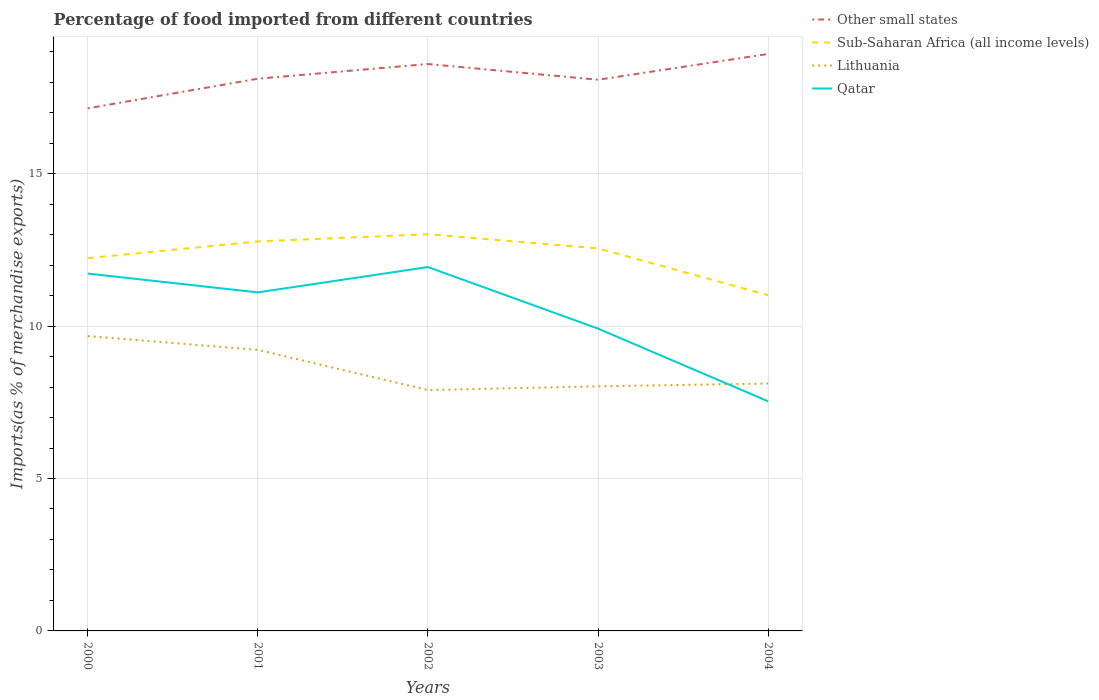How many different coloured lines are there?
Ensure brevity in your answer.  4. Is the number of lines equal to the number of legend labels?
Offer a very short reply. Yes. Across all years, what is the maximum percentage of imports to different countries in Sub-Saharan Africa (all income levels)?
Offer a very short reply. 11.01. What is the total percentage of imports to different countries in Lithuania in the graph?
Offer a terse response. 1.56. What is the difference between the highest and the second highest percentage of imports to different countries in Lithuania?
Your response must be concise. 1.77. What is the difference between the highest and the lowest percentage of imports to different countries in Sub-Saharan Africa (all income levels)?
Provide a succinct answer. 3. Is the percentage of imports to different countries in Lithuania strictly greater than the percentage of imports to different countries in Other small states over the years?
Provide a succinct answer. Yes. How many years are there in the graph?
Your answer should be compact. 5. What is the difference between two consecutive major ticks on the Y-axis?
Offer a very short reply. 5. How are the legend labels stacked?
Make the answer very short. Vertical. What is the title of the graph?
Keep it short and to the point. Percentage of food imported from different countries. What is the label or title of the X-axis?
Ensure brevity in your answer.  Years. What is the label or title of the Y-axis?
Provide a short and direct response. Imports(as % of merchandise exports). What is the Imports(as % of merchandise exports) in Other small states in 2000?
Offer a very short reply. 17.14. What is the Imports(as % of merchandise exports) in Sub-Saharan Africa (all income levels) in 2000?
Your answer should be compact. 12.23. What is the Imports(as % of merchandise exports) of Lithuania in 2000?
Keep it short and to the point. 9.67. What is the Imports(as % of merchandise exports) of Qatar in 2000?
Provide a short and direct response. 11.72. What is the Imports(as % of merchandise exports) in Other small states in 2001?
Your answer should be compact. 18.12. What is the Imports(as % of merchandise exports) of Sub-Saharan Africa (all income levels) in 2001?
Provide a succinct answer. 12.78. What is the Imports(as % of merchandise exports) in Lithuania in 2001?
Ensure brevity in your answer.  9.22. What is the Imports(as % of merchandise exports) of Qatar in 2001?
Make the answer very short. 11.11. What is the Imports(as % of merchandise exports) of Other small states in 2002?
Offer a terse response. 18.6. What is the Imports(as % of merchandise exports) in Sub-Saharan Africa (all income levels) in 2002?
Keep it short and to the point. 13.01. What is the Imports(as % of merchandise exports) in Lithuania in 2002?
Give a very brief answer. 7.9. What is the Imports(as % of merchandise exports) of Qatar in 2002?
Your answer should be very brief. 11.94. What is the Imports(as % of merchandise exports) of Other small states in 2003?
Offer a very short reply. 18.08. What is the Imports(as % of merchandise exports) of Sub-Saharan Africa (all income levels) in 2003?
Provide a succinct answer. 12.55. What is the Imports(as % of merchandise exports) of Lithuania in 2003?
Offer a terse response. 8.02. What is the Imports(as % of merchandise exports) in Qatar in 2003?
Provide a succinct answer. 9.92. What is the Imports(as % of merchandise exports) of Other small states in 2004?
Your answer should be compact. 18.93. What is the Imports(as % of merchandise exports) in Sub-Saharan Africa (all income levels) in 2004?
Provide a succinct answer. 11.01. What is the Imports(as % of merchandise exports) of Lithuania in 2004?
Provide a short and direct response. 8.12. What is the Imports(as % of merchandise exports) in Qatar in 2004?
Your answer should be very brief. 7.53. Across all years, what is the maximum Imports(as % of merchandise exports) of Other small states?
Give a very brief answer. 18.93. Across all years, what is the maximum Imports(as % of merchandise exports) of Sub-Saharan Africa (all income levels)?
Your answer should be compact. 13.01. Across all years, what is the maximum Imports(as % of merchandise exports) in Lithuania?
Provide a short and direct response. 9.67. Across all years, what is the maximum Imports(as % of merchandise exports) in Qatar?
Your answer should be very brief. 11.94. Across all years, what is the minimum Imports(as % of merchandise exports) in Other small states?
Make the answer very short. 17.14. Across all years, what is the minimum Imports(as % of merchandise exports) in Sub-Saharan Africa (all income levels)?
Make the answer very short. 11.01. Across all years, what is the minimum Imports(as % of merchandise exports) in Lithuania?
Provide a short and direct response. 7.9. Across all years, what is the minimum Imports(as % of merchandise exports) of Qatar?
Give a very brief answer. 7.53. What is the total Imports(as % of merchandise exports) in Other small states in the graph?
Your response must be concise. 90.87. What is the total Imports(as % of merchandise exports) in Sub-Saharan Africa (all income levels) in the graph?
Provide a short and direct response. 61.58. What is the total Imports(as % of merchandise exports) of Lithuania in the graph?
Ensure brevity in your answer.  42.93. What is the total Imports(as % of merchandise exports) in Qatar in the graph?
Make the answer very short. 52.22. What is the difference between the Imports(as % of merchandise exports) in Other small states in 2000 and that in 2001?
Ensure brevity in your answer.  -0.97. What is the difference between the Imports(as % of merchandise exports) in Sub-Saharan Africa (all income levels) in 2000 and that in 2001?
Give a very brief answer. -0.55. What is the difference between the Imports(as % of merchandise exports) of Lithuania in 2000 and that in 2001?
Your response must be concise. 0.45. What is the difference between the Imports(as % of merchandise exports) of Qatar in 2000 and that in 2001?
Keep it short and to the point. 0.62. What is the difference between the Imports(as % of merchandise exports) of Other small states in 2000 and that in 2002?
Your response must be concise. -1.45. What is the difference between the Imports(as % of merchandise exports) of Sub-Saharan Africa (all income levels) in 2000 and that in 2002?
Your answer should be very brief. -0.79. What is the difference between the Imports(as % of merchandise exports) in Lithuania in 2000 and that in 2002?
Your response must be concise. 1.77. What is the difference between the Imports(as % of merchandise exports) in Qatar in 2000 and that in 2002?
Provide a succinct answer. -0.21. What is the difference between the Imports(as % of merchandise exports) of Other small states in 2000 and that in 2003?
Your answer should be very brief. -0.94. What is the difference between the Imports(as % of merchandise exports) in Sub-Saharan Africa (all income levels) in 2000 and that in 2003?
Your answer should be very brief. -0.32. What is the difference between the Imports(as % of merchandise exports) of Lithuania in 2000 and that in 2003?
Give a very brief answer. 1.65. What is the difference between the Imports(as % of merchandise exports) of Qatar in 2000 and that in 2003?
Offer a terse response. 1.81. What is the difference between the Imports(as % of merchandise exports) of Other small states in 2000 and that in 2004?
Ensure brevity in your answer.  -1.78. What is the difference between the Imports(as % of merchandise exports) of Sub-Saharan Africa (all income levels) in 2000 and that in 2004?
Ensure brevity in your answer.  1.22. What is the difference between the Imports(as % of merchandise exports) of Lithuania in 2000 and that in 2004?
Your answer should be compact. 1.56. What is the difference between the Imports(as % of merchandise exports) of Qatar in 2000 and that in 2004?
Give a very brief answer. 4.19. What is the difference between the Imports(as % of merchandise exports) in Other small states in 2001 and that in 2002?
Your answer should be very brief. -0.48. What is the difference between the Imports(as % of merchandise exports) in Sub-Saharan Africa (all income levels) in 2001 and that in 2002?
Give a very brief answer. -0.24. What is the difference between the Imports(as % of merchandise exports) of Lithuania in 2001 and that in 2002?
Your answer should be very brief. 1.32. What is the difference between the Imports(as % of merchandise exports) in Qatar in 2001 and that in 2002?
Provide a short and direct response. -0.83. What is the difference between the Imports(as % of merchandise exports) in Other small states in 2001 and that in 2003?
Give a very brief answer. 0.03. What is the difference between the Imports(as % of merchandise exports) in Sub-Saharan Africa (all income levels) in 2001 and that in 2003?
Give a very brief answer. 0.23. What is the difference between the Imports(as % of merchandise exports) of Lithuania in 2001 and that in 2003?
Ensure brevity in your answer.  1.2. What is the difference between the Imports(as % of merchandise exports) in Qatar in 2001 and that in 2003?
Provide a short and direct response. 1.19. What is the difference between the Imports(as % of merchandise exports) of Other small states in 2001 and that in 2004?
Offer a terse response. -0.81. What is the difference between the Imports(as % of merchandise exports) in Sub-Saharan Africa (all income levels) in 2001 and that in 2004?
Provide a short and direct response. 1.76. What is the difference between the Imports(as % of merchandise exports) in Lithuania in 2001 and that in 2004?
Your answer should be very brief. 1.11. What is the difference between the Imports(as % of merchandise exports) in Qatar in 2001 and that in 2004?
Ensure brevity in your answer.  3.57. What is the difference between the Imports(as % of merchandise exports) of Other small states in 2002 and that in 2003?
Your response must be concise. 0.52. What is the difference between the Imports(as % of merchandise exports) of Sub-Saharan Africa (all income levels) in 2002 and that in 2003?
Offer a terse response. 0.46. What is the difference between the Imports(as % of merchandise exports) in Lithuania in 2002 and that in 2003?
Provide a short and direct response. -0.12. What is the difference between the Imports(as % of merchandise exports) in Qatar in 2002 and that in 2003?
Ensure brevity in your answer.  2.02. What is the difference between the Imports(as % of merchandise exports) of Other small states in 2002 and that in 2004?
Your answer should be very brief. -0.33. What is the difference between the Imports(as % of merchandise exports) in Sub-Saharan Africa (all income levels) in 2002 and that in 2004?
Offer a very short reply. 2. What is the difference between the Imports(as % of merchandise exports) of Lithuania in 2002 and that in 2004?
Your response must be concise. -0.21. What is the difference between the Imports(as % of merchandise exports) of Qatar in 2002 and that in 2004?
Give a very brief answer. 4.4. What is the difference between the Imports(as % of merchandise exports) of Other small states in 2003 and that in 2004?
Ensure brevity in your answer.  -0.85. What is the difference between the Imports(as % of merchandise exports) in Sub-Saharan Africa (all income levels) in 2003 and that in 2004?
Your answer should be compact. 1.54. What is the difference between the Imports(as % of merchandise exports) of Lithuania in 2003 and that in 2004?
Provide a short and direct response. -0.09. What is the difference between the Imports(as % of merchandise exports) of Qatar in 2003 and that in 2004?
Your response must be concise. 2.39. What is the difference between the Imports(as % of merchandise exports) of Other small states in 2000 and the Imports(as % of merchandise exports) of Sub-Saharan Africa (all income levels) in 2001?
Keep it short and to the point. 4.37. What is the difference between the Imports(as % of merchandise exports) in Other small states in 2000 and the Imports(as % of merchandise exports) in Lithuania in 2001?
Offer a terse response. 7.92. What is the difference between the Imports(as % of merchandise exports) of Other small states in 2000 and the Imports(as % of merchandise exports) of Qatar in 2001?
Offer a very short reply. 6.04. What is the difference between the Imports(as % of merchandise exports) in Sub-Saharan Africa (all income levels) in 2000 and the Imports(as % of merchandise exports) in Lithuania in 2001?
Provide a short and direct response. 3.01. What is the difference between the Imports(as % of merchandise exports) in Sub-Saharan Africa (all income levels) in 2000 and the Imports(as % of merchandise exports) in Qatar in 2001?
Your response must be concise. 1.12. What is the difference between the Imports(as % of merchandise exports) in Lithuania in 2000 and the Imports(as % of merchandise exports) in Qatar in 2001?
Ensure brevity in your answer.  -1.43. What is the difference between the Imports(as % of merchandise exports) in Other small states in 2000 and the Imports(as % of merchandise exports) in Sub-Saharan Africa (all income levels) in 2002?
Make the answer very short. 4.13. What is the difference between the Imports(as % of merchandise exports) of Other small states in 2000 and the Imports(as % of merchandise exports) of Lithuania in 2002?
Provide a short and direct response. 9.24. What is the difference between the Imports(as % of merchandise exports) in Other small states in 2000 and the Imports(as % of merchandise exports) in Qatar in 2002?
Provide a short and direct response. 5.21. What is the difference between the Imports(as % of merchandise exports) in Sub-Saharan Africa (all income levels) in 2000 and the Imports(as % of merchandise exports) in Lithuania in 2002?
Keep it short and to the point. 4.33. What is the difference between the Imports(as % of merchandise exports) in Sub-Saharan Africa (all income levels) in 2000 and the Imports(as % of merchandise exports) in Qatar in 2002?
Offer a very short reply. 0.29. What is the difference between the Imports(as % of merchandise exports) in Lithuania in 2000 and the Imports(as % of merchandise exports) in Qatar in 2002?
Make the answer very short. -2.26. What is the difference between the Imports(as % of merchandise exports) of Other small states in 2000 and the Imports(as % of merchandise exports) of Sub-Saharan Africa (all income levels) in 2003?
Give a very brief answer. 4.59. What is the difference between the Imports(as % of merchandise exports) of Other small states in 2000 and the Imports(as % of merchandise exports) of Lithuania in 2003?
Offer a terse response. 9.12. What is the difference between the Imports(as % of merchandise exports) in Other small states in 2000 and the Imports(as % of merchandise exports) in Qatar in 2003?
Provide a short and direct response. 7.23. What is the difference between the Imports(as % of merchandise exports) of Sub-Saharan Africa (all income levels) in 2000 and the Imports(as % of merchandise exports) of Lithuania in 2003?
Offer a terse response. 4.2. What is the difference between the Imports(as % of merchandise exports) in Sub-Saharan Africa (all income levels) in 2000 and the Imports(as % of merchandise exports) in Qatar in 2003?
Provide a short and direct response. 2.31. What is the difference between the Imports(as % of merchandise exports) of Lithuania in 2000 and the Imports(as % of merchandise exports) of Qatar in 2003?
Provide a succinct answer. -0.24. What is the difference between the Imports(as % of merchandise exports) of Other small states in 2000 and the Imports(as % of merchandise exports) of Sub-Saharan Africa (all income levels) in 2004?
Keep it short and to the point. 6.13. What is the difference between the Imports(as % of merchandise exports) of Other small states in 2000 and the Imports(as % of merchandise exports) of Lithuania in 2004?
Offer a terse response. 9.03. What is the difference between the Imports(as % of merchandise exports) of Other small states in 2000 and the Imports(as % of merchandise exports) of Qatar in 2004?
Offer a terse response. 9.61. What is the difference between the Imports(as % of merchandise exports) in Sub-Saharan Africa (all income levels) in 2000 and the Imports(as % of merchandise exports) in Lithuania in 2004?
Ensure brevity in your answer.  4.11. What is the difference between the Imports(as % of merchandise exports) of Sub-Saharan Africa (all income levels) in 2000 and the Imports(as % of merchandise exports) of Qatar in 2004?
Keep it short and to the point. 4.7. What is the difference between the Imports(as % of merchandise exports) of Lithuania in 2000 and the Imports(as % of merchandise exports) of Qatar in 2004?
Your answer should be very brief. 2.14. What is the difference between the Imports(as % of merchandise exports) in Other small states in 2001 and the Imports(as % of merchandise exports) in Sub-Saharan Africa (all income levels) in 2002?
Keep it short and to the point. 5.1. What is the difference between the Imports(as % of merchandise exports) of Other small states in 2001 and the Imports(as % of merchandise exports) of Lithuania in 2002?
Offer a very short reply. 10.21. What is the difference between the Imports(as % of merchandise exports) of Other small states in 2001 and the Imports(as % of merchandise exports) of Qatar in 2002?
Provide a succinct answer. 6.18. What is the difference between the Imports(as % of merchandise exports) in Sub-Saharan Africa (all income levels) in 2001 and the Imports(as % of merchandise exports) in Lithuania in 2002?
Offer a very short reply. 4.88. What is the difference between the Imports(as % of merchandise exports) in Sub-Saharan Africa (all income levels) in 2001 and the Imports(as % of merchandise exports) in Qatar in 2002?
Your answer should be compact. 0.84. What is the difference between the Imports(as % of merchandise exports) in Lithuania in 2001 and the Imports(as % of merchandise exports) in Qatar in 2002?
Ensure brevity in your answer.  -2.72. What is the difference between the Imports(as % of merchandise exports) of Other small states in 2001 and the Imports(as % of merchandise exports) of Sub-Saharan Africa (all income levels) in 2003?
Your answer should be compact. 5.57. What is the difference between the Imports(as % of merchandise exports) of Other small states in 2001 and the Imports(as % of merchandise exports) of Lithuania in 2003?
Give a very brief answer. 10.09. What is the difference between the Imports(as % of merchandise exports) of Other small states in 2001 and the Imports(as % of merchandise exports) of Qatar in 2003?
Your answer should be compact. 8.2. What is the difference between the Imports(as % of merchandise exports) in Sub-Saharan Africa (all income levels) in 2001 and the Imports(as % of merchandise exports) in Lithuania in 2003?
Offer a terse response. 4.75. What is the difference between the Imports(as % of merchandise exports) in Sub-Saharan Africa (all income levels) in 2001 and the Imports(as % of merchandise exports) in Qatar in 2003?
Offer a very short reply. 2.86. What is the difference between the Imports(as % of merchandise exports) of Lithuania in 2001 and the Imports(as % of merchandise exports) of Qatar in 2003?
Make the answer very short. -0.7. What is the difference between the Imports(as % of merchandise exports) in Other small states in 2001 and the Imports(as % of merchandise exports) in Sub-Saharan Africa (all income levels) in 2004?
Offer a very short reply. 7.1. What is the difference between the Imports(as % of merchandise exports) of Other small states in 2001 and the Imports(as % of merchandise exports) of Lithuania in 2004?
Your response must be concise. 10. What is the difference between the Imports(as % of merchandise exports) in Other small states in 2001 and the Imports(as % of merchandise exports) in Qatar in 2004?
Your response must be concise. 10.58. What is the difference between the Imports(as % of merchandise exports) of Sub-Saharan Africa (all income levels) in 2001 and the Imports(as % of merchandise exports) of Lithuania in 2004?
Ensure brevity in your answer.  4.66. What is the difference between the Imports(as % of merchandise exports) of Sub-Saharan Africa (all income levels) in 2001 and the Imports(as % of merchandise exports) of Qatar in 2004?
Your response must be concise. 5.25. What is the difference between the Imports(as % of merchandise exports) in Lithuania in 2001 and the Imports(as % of merchandise exports) in Qatar in 2004?
Keep it short and to the point. 1.69. What is the difference between the Imports(as % of merchandise exports) in Other small states in 2002 and the Imports(as % of merchandise exports) in Sub-Saharan Africa (all income levels) in 2003?
Provide a short and direct response. 6.05. What is the difference between the Imports(as % of merchandise exports) in Other small states in 2002 and the Imports(as % of merchandise exports) in Lithuania in 2003?
Ensure brevity in your answer.  10.57. What is the difference between the Imports(as % of merchandise exports) in Other small states in 2002 and the Imports(as % of merchandise exports) in Qatar in 2003?
Keep it short and to the point. 8.68. What is the difference between the Imports(as % of merchandise exports) of Sub-Saharan Africa (all income levels) in 2002 and the Imports(as % of merchandise exports) of Lithuania in 2003?
Your response must be concise. 4.99. What is the difference between the Imports(as % of merchandise exports) in Sub-Saharan Africa (all income levels) in 2002 and the Imports(as % of merchandise exports) in Qatar in 2003?
Make the answer very short. 3.1. What is the difference between the Imports(as % of merchandise exports) in Lithuania in 2002 and the Imports(as % of merchandise exports) in Qatar in 2003?
Give a very brief answer. -2.02. What is the difference between the Imports(as % of merchandise exports) in Other small states in 2002 and the Imports(as % of merchandise exports) in Sub-Saharan Africa (all income levels) in 2004?
Offer a terse response. 7.58. What is the difference between the Imports(as % of merchandise exports) of Other small states in 2002 and the Imports(as % of merchandise exports) of Lithuania in 2004?
Provide a short and direct response. 10.48. What is the difference between the Imports(as % of merchandise exports) of Other small states in 2002 and the Imports(as % of merchandise exports) of Qatar in 2004?
Give a very brief answer. 11.06. What is the difference between the Imports(as % of merchandise exports) in Sub-Saharan Africa (all income levels) in 2002 and the Imports(as % of merchandise exports) in Lithuania in 2004?
Make the answer very short. 4.9. What is the difference between the Imports(as % of merchandise exports) in Sub-Saharan Africa (all income levels) in 2002 and the Imports(as % of merchandise exports) in Qatar in 2004?
Ensure brevity in your answer.  5.48. What is the difference between the Imports(as % of merchandise exports) of Lithuania in 2002 and the Imports(as % of merchandise exports) of Qatar in 2004?
Offer a very short reply. 0.37. What is the difference between the Imports(as % of merchandise exports) in Other small states in 2003 and the Imports(as % of merchandise exports) in Sub-Saharan Africa (all income levels) in 2004?
Ensure brevity in your answer.  7.07. What is the difference between the Imports(as % of merchandise exports) of Other small states in 2003 and the Imports(as % of merchandise exports) of Lithuania in 2004?
Provide a short and direct response. 9.97. What is the difference between the Imports(as % of merchandise exports) in Other small states in 2003 and the Imports(as % of merchandise exports) in Qatar in 2004?
Your response must be concise. 10.55. What is the difference between the Imports(as % of merchandise exports) of Sub-Saharan Africa (all income levels) in 2003 and the Imports(as % of merchandise exports) of Lithuania in 2004?
Ensure brevity in your answer.  4.44. What is the difference between the Imports(as % of merchandise exports) of Sub-Saharan Africa (all income levels) in 2003 and the Imports(as % of merchandise exports) of Qatar in 2004?
Offer a terse response. 5.02. What is the difference between the Imports(as % of merchandise exports) of Lithuania in 2003 and the Imports(as % of merchandise exports) of Qatar in 2004?
Provide a succinct answer. 0.49. What is the average Imports(as % of merchandise exports) of Other small states per year?
Your answer should be very brief. 18.17. What is the average Imports(as % of merchandise exports) in Sub-Saharan Africa (all income levels) per year?
Your response must be concise. 12.32. What is the average Imports(as % of merchandise exports) of Lithuania per year?
Your answer should be very brief. 8.59. What is the average Imports(as % of merchandise exports) in Qatar per year?
Keep it short and to the point. 10.44. In the year 2000, what is the difference between the Imports(as % of merchandise exports) in Other small states and Imports(as % of merchandise exports) in Sub-Saharan Africa (all income levels)?
Your answer should be compact. 4.92. In the year 2000, what is the difference between the Imports(as % of merchandise exports) of Other small states and Imports(as % of merchandise exports) of Lithuania?
Offer a very short reply. 7.47. In the year 2000, what is the difference between the Imports(as % of merchandise exports) in Other small states and Imports(as % of merchandise exports) in Qatar?
Your answer should be very brief. 5.42. In the year 2000, what is the difference between the Imports(as % of merchandise exports) in Sub-Saharan Africa (all income levels) and Imports(as % of merchandise exports) in Lithuania?
Make the answer very short. 2.55. In the year 2000, what is the difference between the Imports(as % of merchandise exports) in Sub-Saharan Africa (all income levels) and Imports(as % of merchandise exports) in Qatar?
Your answer should be very brief. 0.51. In the year 2000, what is the difference between the Imports(as % of merchandise exports) in Lithuania and Imports(as % of merchandise exports) in Qatar?
Your answer should be compact. -2.05. In the year 2001, what is the difference between the Imports(as % of merchandise exports) of Other small states and Imports(as % of merchandise exports) of Sub-Saharan Africa (all income levels)?
Your response must be concise. 5.34. In the year 2001, what is the difference between the Imports(as % of merchandise exports) in Other small states and Imports(as % of merchandise exports) in Lithuania?
Your answer should be very brief. 8.89. In the year 2001, what is the difference between the Imports(as % of merchandise exports) of Other small states and Imports(as % of merchandise exports) of Qatar?
Keep it short and to the point. 7.01. In the year 2001, what is the difference between the Imports(as % of merchandise exports) of Sub-Saharan Africa (all income levels) and Imports(as % of merchandise exports) of Lithuania?
Provide a short and direct response. 3.56. In the year 2001, what is the difference between the Imports(as % of merchandise exports) of Sub-Saharan Africa (all income levels) and Imports(as % of merchandise exports) of Qatar?
Offer a terse response. 1.67. In the year 2001, what is the difference between the Imports(as % of merchandise exports) in Lithuania and Imports(as % of merchandise exports) in Qatar?
Provide a short and direct response. -1.89. In the year 2002, what is the difference between the Imports(as % of merchandise exports) of Other small states and Imports(as % of merchandise exports) of Sub-Saharan Africa (all income levels)?
Keep it short and to the point. 5.58. In the year 2002, what is the difference between the Imports(as % of merchandise exports) of Other small states and Imports(as % of merchandise exports) of Lithuania?
Keep it short and to the point. 10.7. In the year 2002, what is the difference between the Imports(as % of merchandise exports) of Other small states and Imports(as % of merchandise exports) of Qatar?
Make the answer very short. 6.66. In the year 2002, what is the difference between the Imports(as % of merchandise exports) of Sub-Saharan Africa (all income levels) and Imports(as % of merchandise exports) of Lithuania?
Make the answer very short. 5.11. In the year 2002, what is the difference between the Imports(as % of merchandise exports) in Sub-Saharan Africa (all income levels) and Imports(as % of merchandise exports) in Qatar?
Offer a very short reply. 1.08. In the year 2002, what is the difference between the Imports(as % of merchandise exports) in Lithuania and Imports(as % of merchandise exports) in Qatar?
Make the answer very short. -4.04. In the year 2003, what is the difference between the Imports(as % of merchandise exports) of Other small states and Imports(as % of merchandise exports) of Sub-Saharan Africa (all income levels)?
Your answer should be compact. 5.53. In the year 2003, what is the difference between the Imports(as % of merchandise exports) of Other small states and Imports(as % of merchandise exports) of Lithuania?
Your answer should be compact. 10.06. In the year 2003, what is the difference between the Imports(as % of merchandise exports) of Other small states and Imports(as % of merchandise exports) of Qatar?
Give a very brief answer. 8.16. In the year 2003, what is the difference between the Imports(as % of merchandise exports) of Sub-Saharan Africa (all income levels) and Imports(as % of merchandise exports) of Lithuania?
Your answer should be very brief. 4.53. In the year 2003, what is the difference between the Imports(as % of merchandise exports) of Sub-Saharan Africa (all income levels) and Imports(as % of merchandise exports) of Qatar?
Your answer should be compact. 2.63. In the year 2003, what is the difference between the Imports(as % of merchandise exports) in Lithuania and Imports(as % of merchandise exports) in Qatar?
Offer a terse response. -1.89. In the year 2004, what is the difference between the Imports(as % of merchandise exports) of Other small states and Imports(as % of merchandise exports) of Sub-Saharan Africa (all income levels)?
Give a very brief answer. 7.92. In the year 2004, what is the difference between the Imports(as % of merchandise exports) of Other small states and Imports(as % of merchandise exports) of Lithuania?
Give a very brief answer. 10.81. In the year 2004, what is the difference between the Imports(as % of merchandise exports) of Other small states and Imports(as % of merchandise exports) of Qatar?
Your response must be concise. 11.4. In the year 2004, what is the difference between the Imports(as % of merchandise exports) of Sub-Saharan Africa (all income levels) and Imports(as % of merchandise exports) of Lithuania?
Give a very brief answer. 2.9. In the year 2004, what is the difference between the Imports(as % of merchandise exports) of Sub-Saharan Africa (all income levels) and Imports(as % of merchandise exports) of Qatar?
Provide a short and direct response. 3.48. In the year 2004, what is the difference between the Imports(as % of merchandise exports) in Lithuania and Imports(as % of merchandise exports) in Qatar?
Your response must be concise. 0.58. What is the ratio of the Imports(as % of merchandise exports) in Other small states in 2000 to that in 2001?
Provide a succinct answer. 0.95. What is the ratio of the Imports(as % of merchandise exports) of Lithuania in 2000 to that in 2001?
Your answer should be very brief. 1.05. What is the ratio of the Imports(as % of merchandise exports) of Qatar in 2000 to that in 2001?
Ensure brevity in your answer.  1.06. What is the ratio of the Imports(as % of merchandise exports) of Other small states in 2000 to that in 2002?
Offer a very short reply. 0.92. What is the ratio of the Imports(as % of merchandise exports) of Sub-Saharan Africa (all income levels) in 2000 to that in 2002?
Your response must be concise. 0.94. What is the ratio of the Imports(as % of merchandise exports) of Lithuania in 2000 to that in 2002?
Keep it short and to the point. 1.22. What is the ratio of the Imports(as % of merchandise exports) in Qatar in 2000 to that in 2002?
Offer a terse response. 0.98. What is the ratio of the Imports(as % of merchandise exports) of Other small states in 2000 to that in 2003?
Provide a short and direct response. 0.95. What is the ratio of the Imports(as % of merchandise exports) in Sub-Saharan Africa (all income levels) in 2000 to that in 2003?
Your response must be concise. 0.97. What is the ratio of the Imports(as % of merchandise exports) in Lithuania in 2000 to that in 2003?
Provide a short and direct response. 1.21. What is the ratio of the Imports(as % of merchandise exports) in Qatar in 2000 to that in 2003?
Offer a terse response. 1.18. What is the ratio of the Imports(as % of merchandise exports) in Other small states in 2000 to that in 2004?
Make the answer very short. 0.91. What is the ratio of the Imports(as % of merchandise exports) in Sub-Saharan Africa (all income levels) in 2000 to that in 2004?
Your response must be concise. 1.11. What is the ratio of the Imports(as % of merchandise exports) of Lithuania in 2000 to that in 2004?
Your response must be concise. 1.19. What is the ratio of the Imports(as % of merchandise exports) of Qatar in 2000 to that in 2004?
Provide a short and direct response. 1.56. What is the ratio of the Imports(as % of merchandise exports) in Other small states in 2001 to that in 2002?
Offer a very short reply. 0.97. What is the ratio of the Imports(as % of merchandise exports) of Sub-Saharan Africa (all income levels) in 2001 to that in 2002?
Make the answer very short. 0.98. What is the ratio of the Imports(as % of merchandise exports) in Lithuania in 2001 to that in 2002?
Your response must be concise. 1.17. What is the ratio of the Imports(as % of merchandise exports) in Qatar in 2001 to that in 2002?
Keep it short and to the point. 0.93. What is the ratio of the Imports(as % of merchandise exports) in Other small states in 2001 to that in 2003?
Provide a succinct answer. 1. What is the ratio of the Imports(as % of merchandise exports) in Sub-Saharan Africa (all income levels) in 2001 to that in 2003?
Offer a terse response. 1.02. What is the ratio of the Imports(as % of merchandise exports) in Lithuania in 2001 to that in 2003?
Your answer should be compact. 1.15. What is the ratio of the Imports(as % of merchandise exports) of Qatar in 2001 to that in 2003?
Provide a succinct answer. 1.12. What is the ratio of the Imports(as % of merchandise exports) of Other small states in 2001 to that in 2004?
Ensure brevity in your answer.  0.96. What is the ratio of the Imports(as % of merchandise exports) of Sub-Saharan Africa (all income levels) in 2001 to that in 2004?
Make the answer very short. 1.16. What is the ratio of the Imports(as % of merchandise exports) in Lithuania in 2001 to that in 2004?
Make the answer very short. 1.14. What is the ratio of the Imports(as % of merchandise exports) in Qatar in 2001 to that in 2004?
Your answer should be very brief. 1.47. What is the ratio of the Imports(as % of merchandise exports) of Other small states in 2002 to that in 2003?
Offer a very short reply. 1.03. What is the ratio of the Imports(as % of merchandise exports) in Sub-Saharan Africa (all income levels) in 2002 to that in 2003?
Ensure brevity in your answer.  1.04. What is the ratio of the Imports(as % of merchandise exports) of Lithuania in 2002 to that in 2003?
Your response must be concise. 0.98. What is the ratio of the Imports(as % of merchandise exports) in Qatar in 2002 to that in 2003?
Offer a terse response. 1.2. What is the ratio of the Imports(as % of merchandise exports) in Other small states in 2002 to that in 2004?
Offer a very short reply. 0.98. What is the ratio of the Imports(as % of merchandise exports) of Sub-Saharan Africa (all income levels) in 2002 to that in 2004?
Provide a short and direct response. 1.18. What is the ratio of the Imports(as % of merchandise exports) of Lithuania in 2002 to that in 2004?
Offer a terse response. 0.97. What is the ratio of the Imports(as % of merchandise exports) of Qatar in 2002 to that in 2004?
Your response must be concise. 1.58. What is the ratio of the Imports(as % of merchandise exports) of Other small states in 2003 to that in 2004?
Provide a short and direct response. 0.96. What is the ratio of the Imports(as % of merchandise exports) in Sub-Saharan Africa (all income levels) in 2003 to that in 2004?
Keep it short and to the point. 1.14. What is the ratio of the Imports(as % of merchandise exports) of Qatar in 2003 to that in 2004?
Provide a succinct answer. 1.32. What is the difference between the highest and the second highest Imports(as % of merchandise exports) in Other small states?
Provide a short and direct response. 0.33. What is the difference between the highest and the second highest Imports(as % of merchandise exports) of Sub-Saharan Africa (all income levels)?
Offer a terse response. 0.24. What is the difference between the highest and the second highest Imports(as % of merchandise exports) in Lithuania?
Your answer should be compact. 0.45. What is the difference between the highest and the second highest Imports(as % of merchandise exports) in Qatar?
Offer a terse response. 0.21. What is the difference between the highest and the lowest Imports(as % of merchandise exports) in Other small states?
Your response must be concise. 1.78. What is the difference between the highest and the lowest Imports(as % of merchandise exports) in Sub-Saharan Africa (all income levels)?
Your answer should be compact. 2. What is the difference between the highest and the lowest Imports(as % of merchandise exports) of Lithuania?
Provide a short and direct response. 1.77. What is the difference between the highest and the lowest Imports(as % of merchandise exports) in Qatar?
Keep it short and to the point. 4.4. 